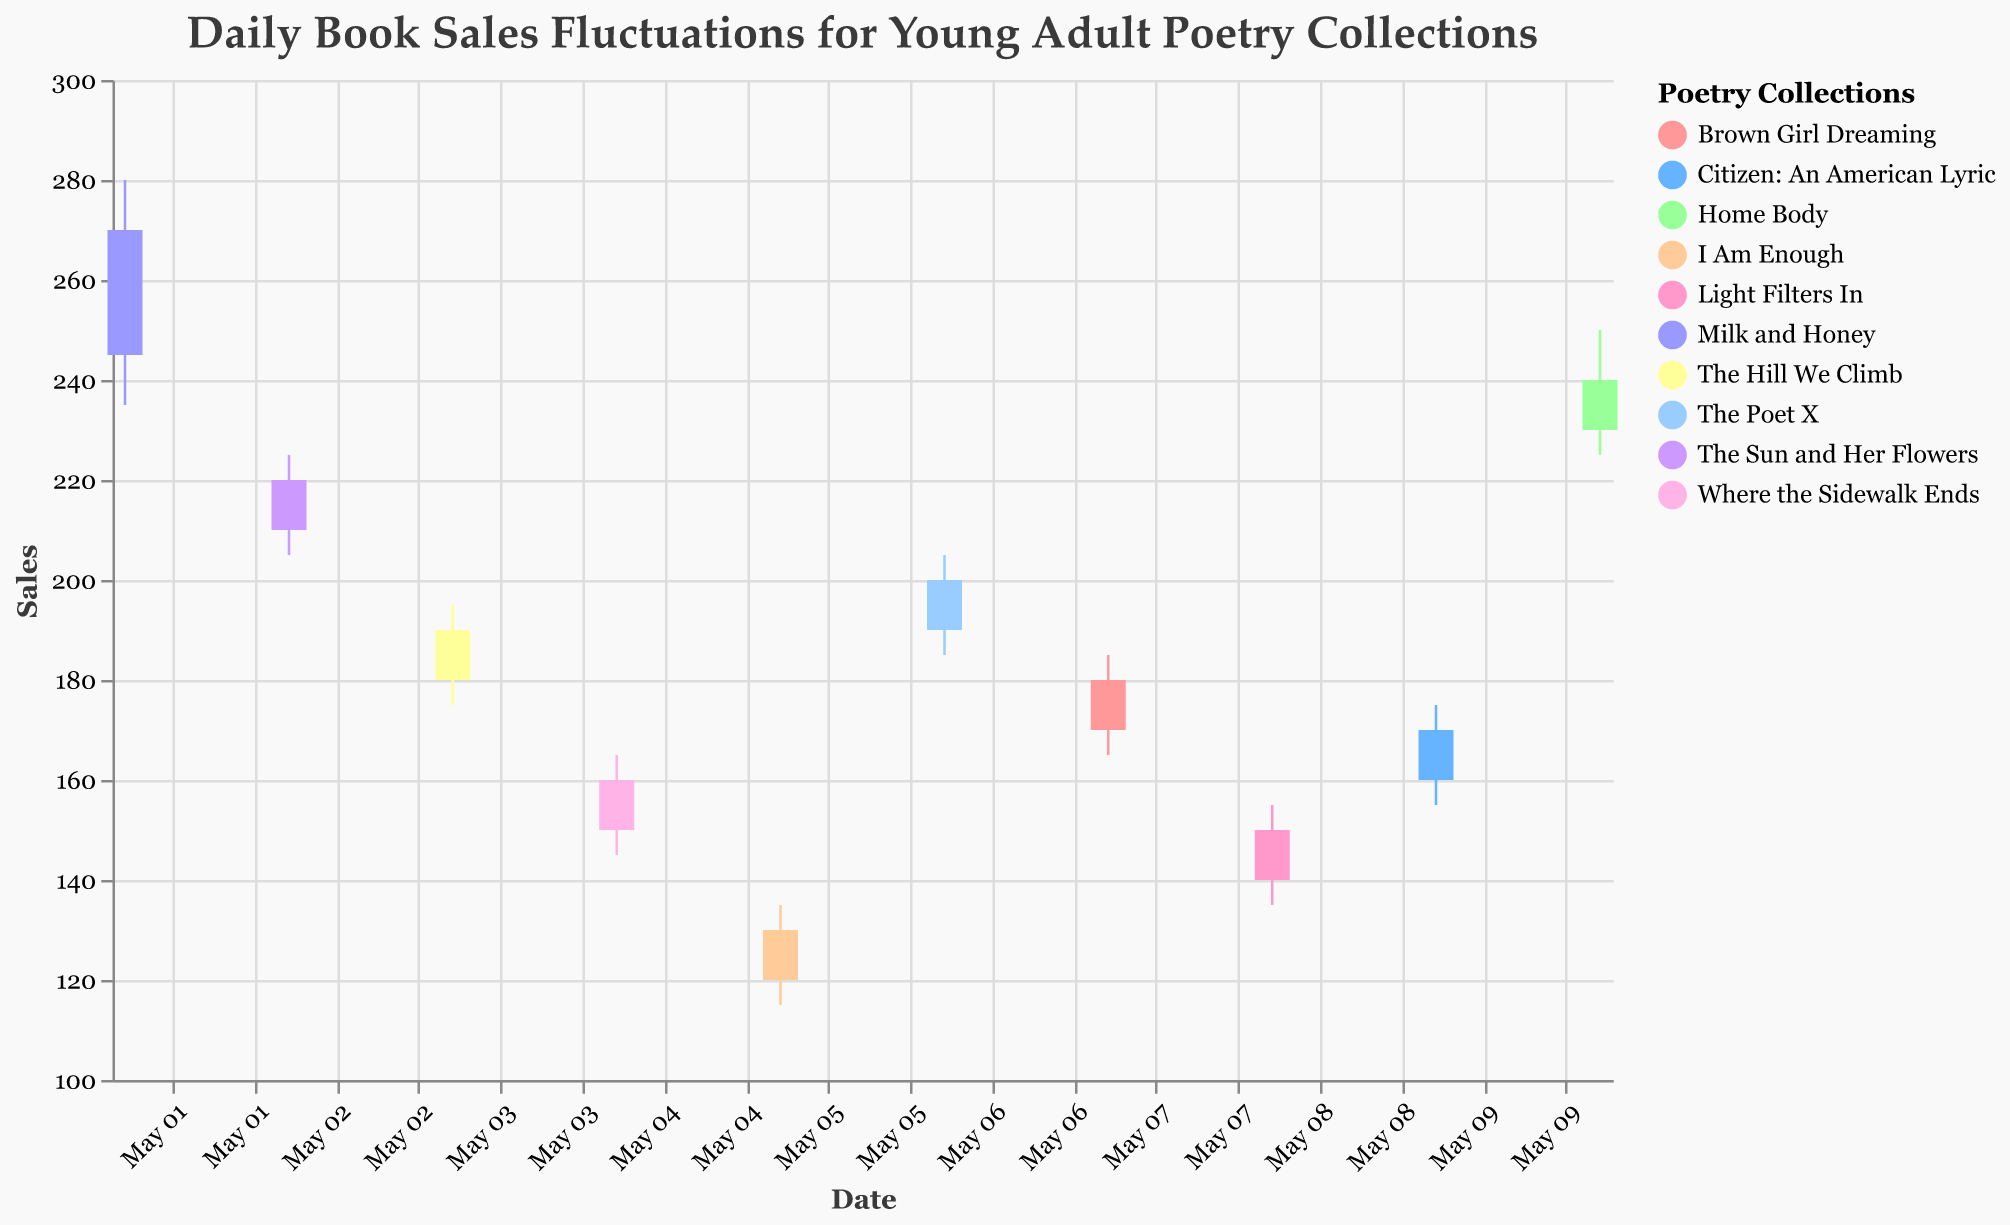What is the title of the chart? The title of the chart is at the top of the figure. It is written in a readable font and color.
Answer: Daily Book Sales Fluctuations for Young Adult Poetry Collections Which book had the highest close sale on May 6? The figure includes the sales data for various books by date. On May 6, "The Poet X" had the highest close sale at 200.
Answer: The Poet X How does the sales volatility of "Milk and Honey" compare to "Home Body"? "Milk and Honey" has sales fluctuating between a low of 235 and a high of 280, while "Home Body" fluctuates between a low of 225 and a high of 250. "Milk and Honey" has a wider range of sales volatility compared to "Home Body".
Answer: Milk and Honey has greater volatility On which date did "Citizen: An American Lyric" have its highest sales? By looking at the chart, one can find the highest point of sales for the book "Citizen: An American Lyric" visually. This book reached its highest sale at 175 on May 9.
Answer: May 9 How many days had "The Hill We Climb" close sales lower than the open sales? By examining the open and close values for "The Hill We Climb", on May 3, the open value was 180 and the close value was 190, which means there are zero days where the close sales were lower than the open sales for this book.
Answer: 0 days Which book shows the smallest range between its high and low sales? The smallest range can be calculated by subtracting the low value from the high value for each book. "Where the Sidewalk Ends" shows the smallest range (165 - 145 = 20).
Answer: Where the Sidewalk Ends Which book had an increase in sales from open to close on May 8? Checking the open and close values for May 8, "Light Filters In" had an open value of 140 and a close value of 150.
Answer: Light Filters In Among the books listed, which one had the highest opening sales value across all dates? Reviewing the open values of all books on different dates, "Milk and Honey" had the highest opening value at 245 on May 1.
Answer: Milk and Honey 